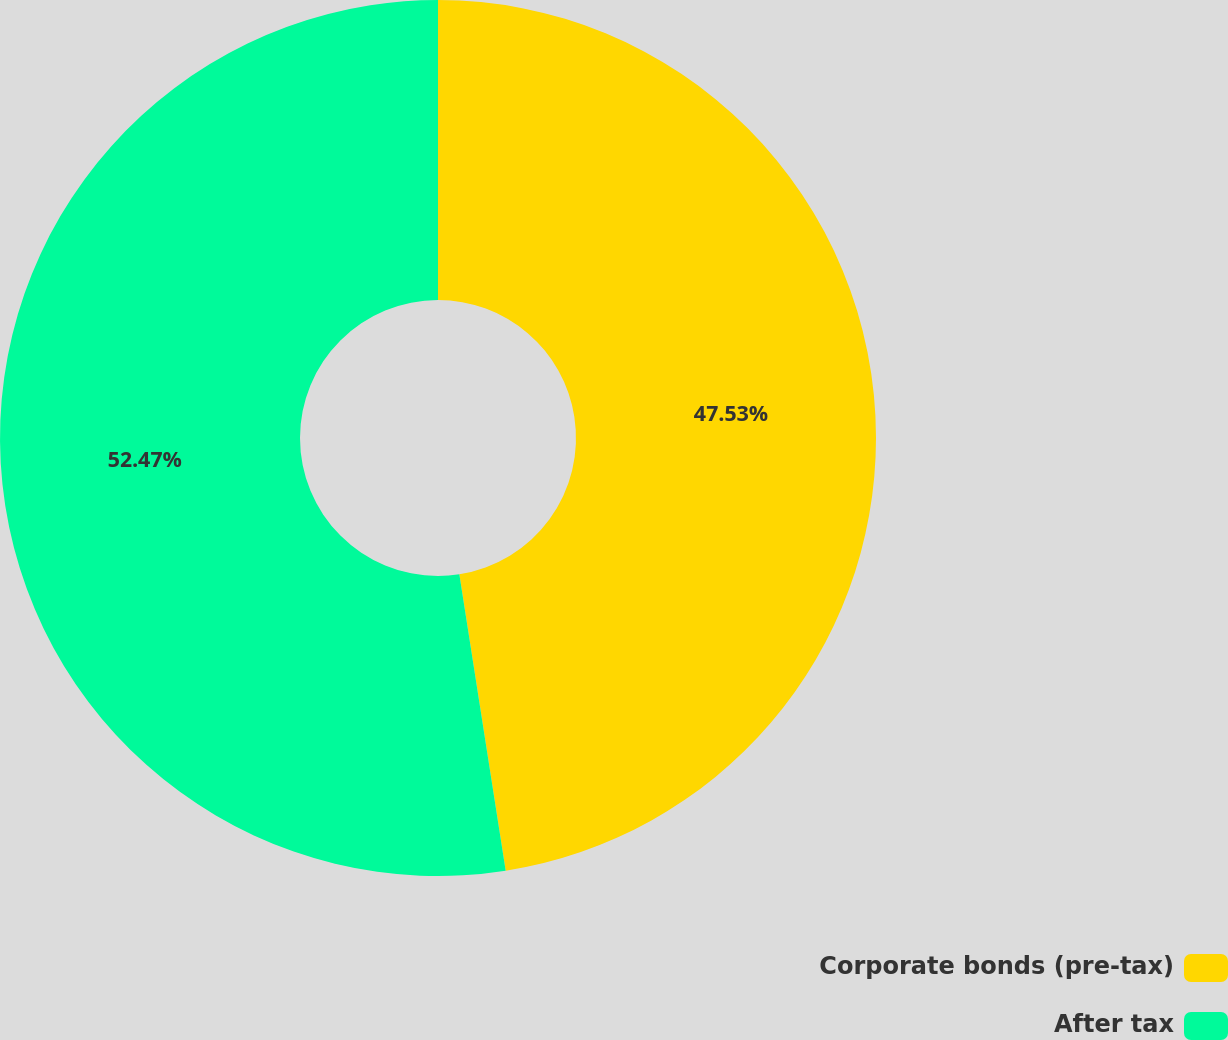Convert chart. <chart><loc_0><loc_0><loc_500><loc_500><pie_chart><fcel>Corporate bonds (pre-tax)<fcel>After tax<nl><fcel>47.53%<fcel>52.47%<nl></chart> 